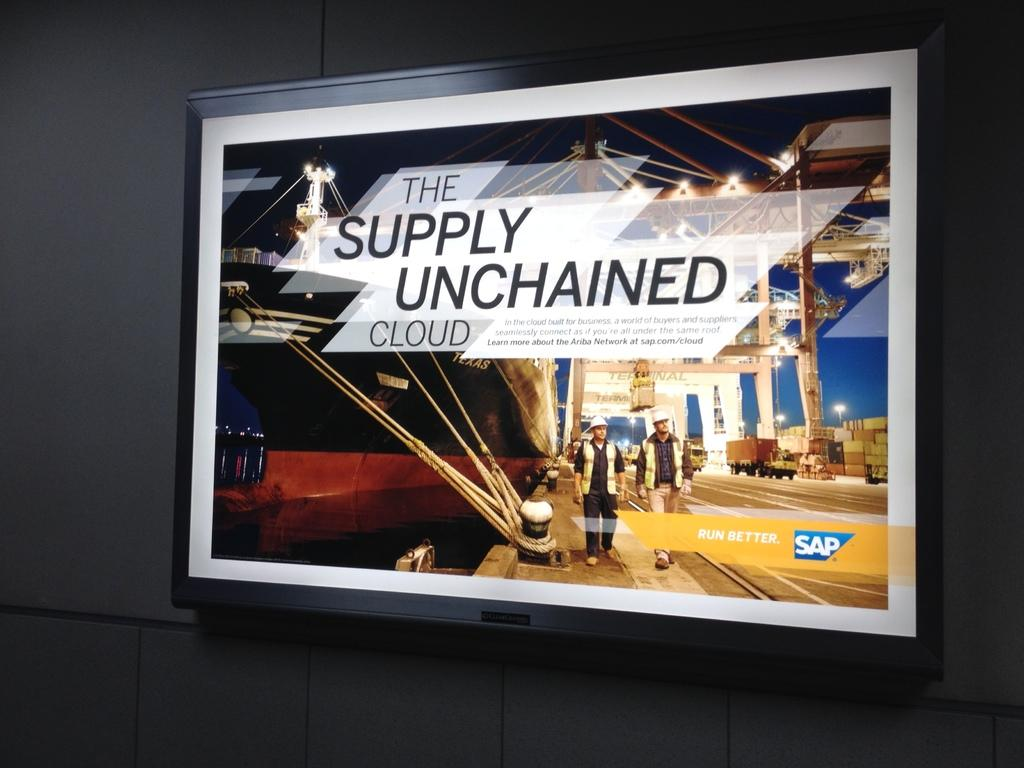<image>
Render a clear and concise summary of the photo. An advertisement for SAP promises things will run better. 